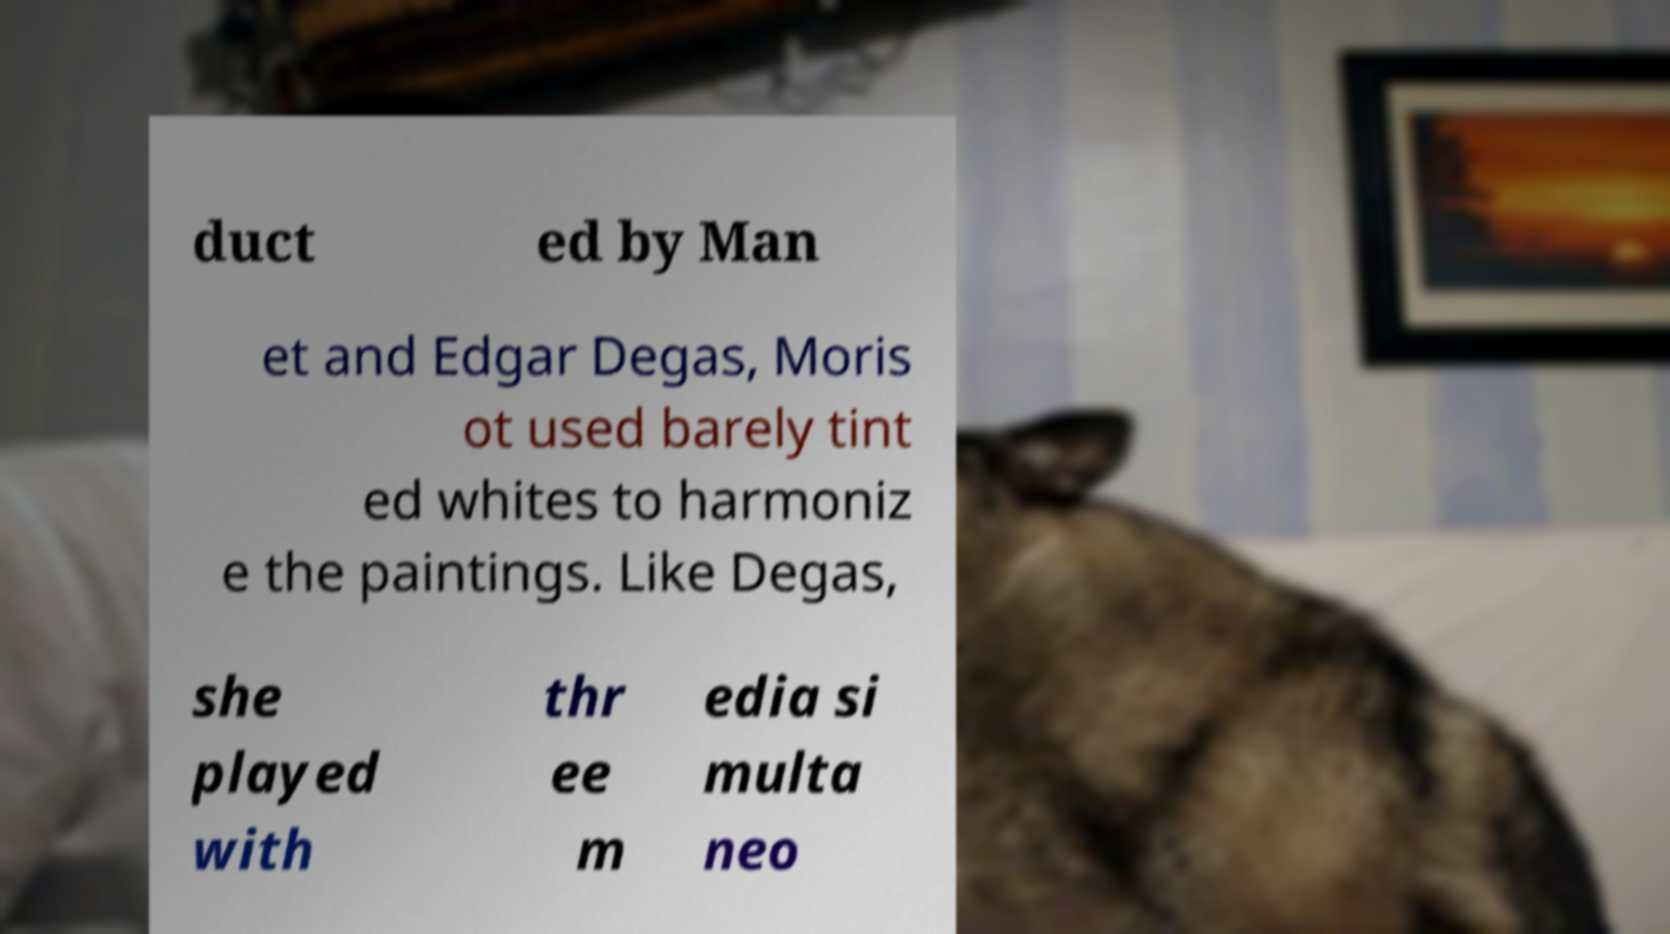Please identify and transcribe the text found in this image. duct ed by Man et and Edgar Degas, Moris ot used barely tint ed whites to harmoniz e the paintings. Like Degas, she played with thr ee m edia si multa neo 